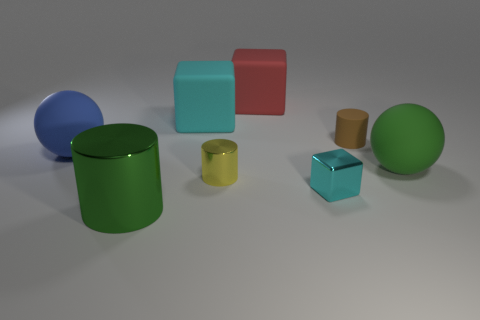Do the brown matte thing and the cyan block that is behind the tiny cyan shiny cube have the same size?
Keep it short and to the point. No. What number of small objects are yellow cylinders or purple balls?
Your response must be concise. 1. Is the number of large blue matte objects greater than the number of red metallic blocks?
Your response must be concise. Yes. There is a red rubber cube to the left of the big matte sphere right of the brown cylinder; how many cyan metallic blocks are in front of it?
Your answer should be very brief. 1. What is the shape of the big cyan rubber thing?
Provide a short and direct response. Cube. What number of other things are there of the same material as the green sphere
Provide a short and direct response. 4. Do the cyan matte object and the brown rubber object have the same size?
Keep it short and to the point. No. What is the shape of the green object to the right of the small cyan thing?
Provide a short and direct response. Sphere. What color is the sphere that is to the left of the cylinder in front of the tiny shiny cube?
Your answer should be very brief. Blue. There is a big green object left of the red cube; is it the same shape as the tiny thing behind the green sphere?
Offer a very short reply. Yes. 